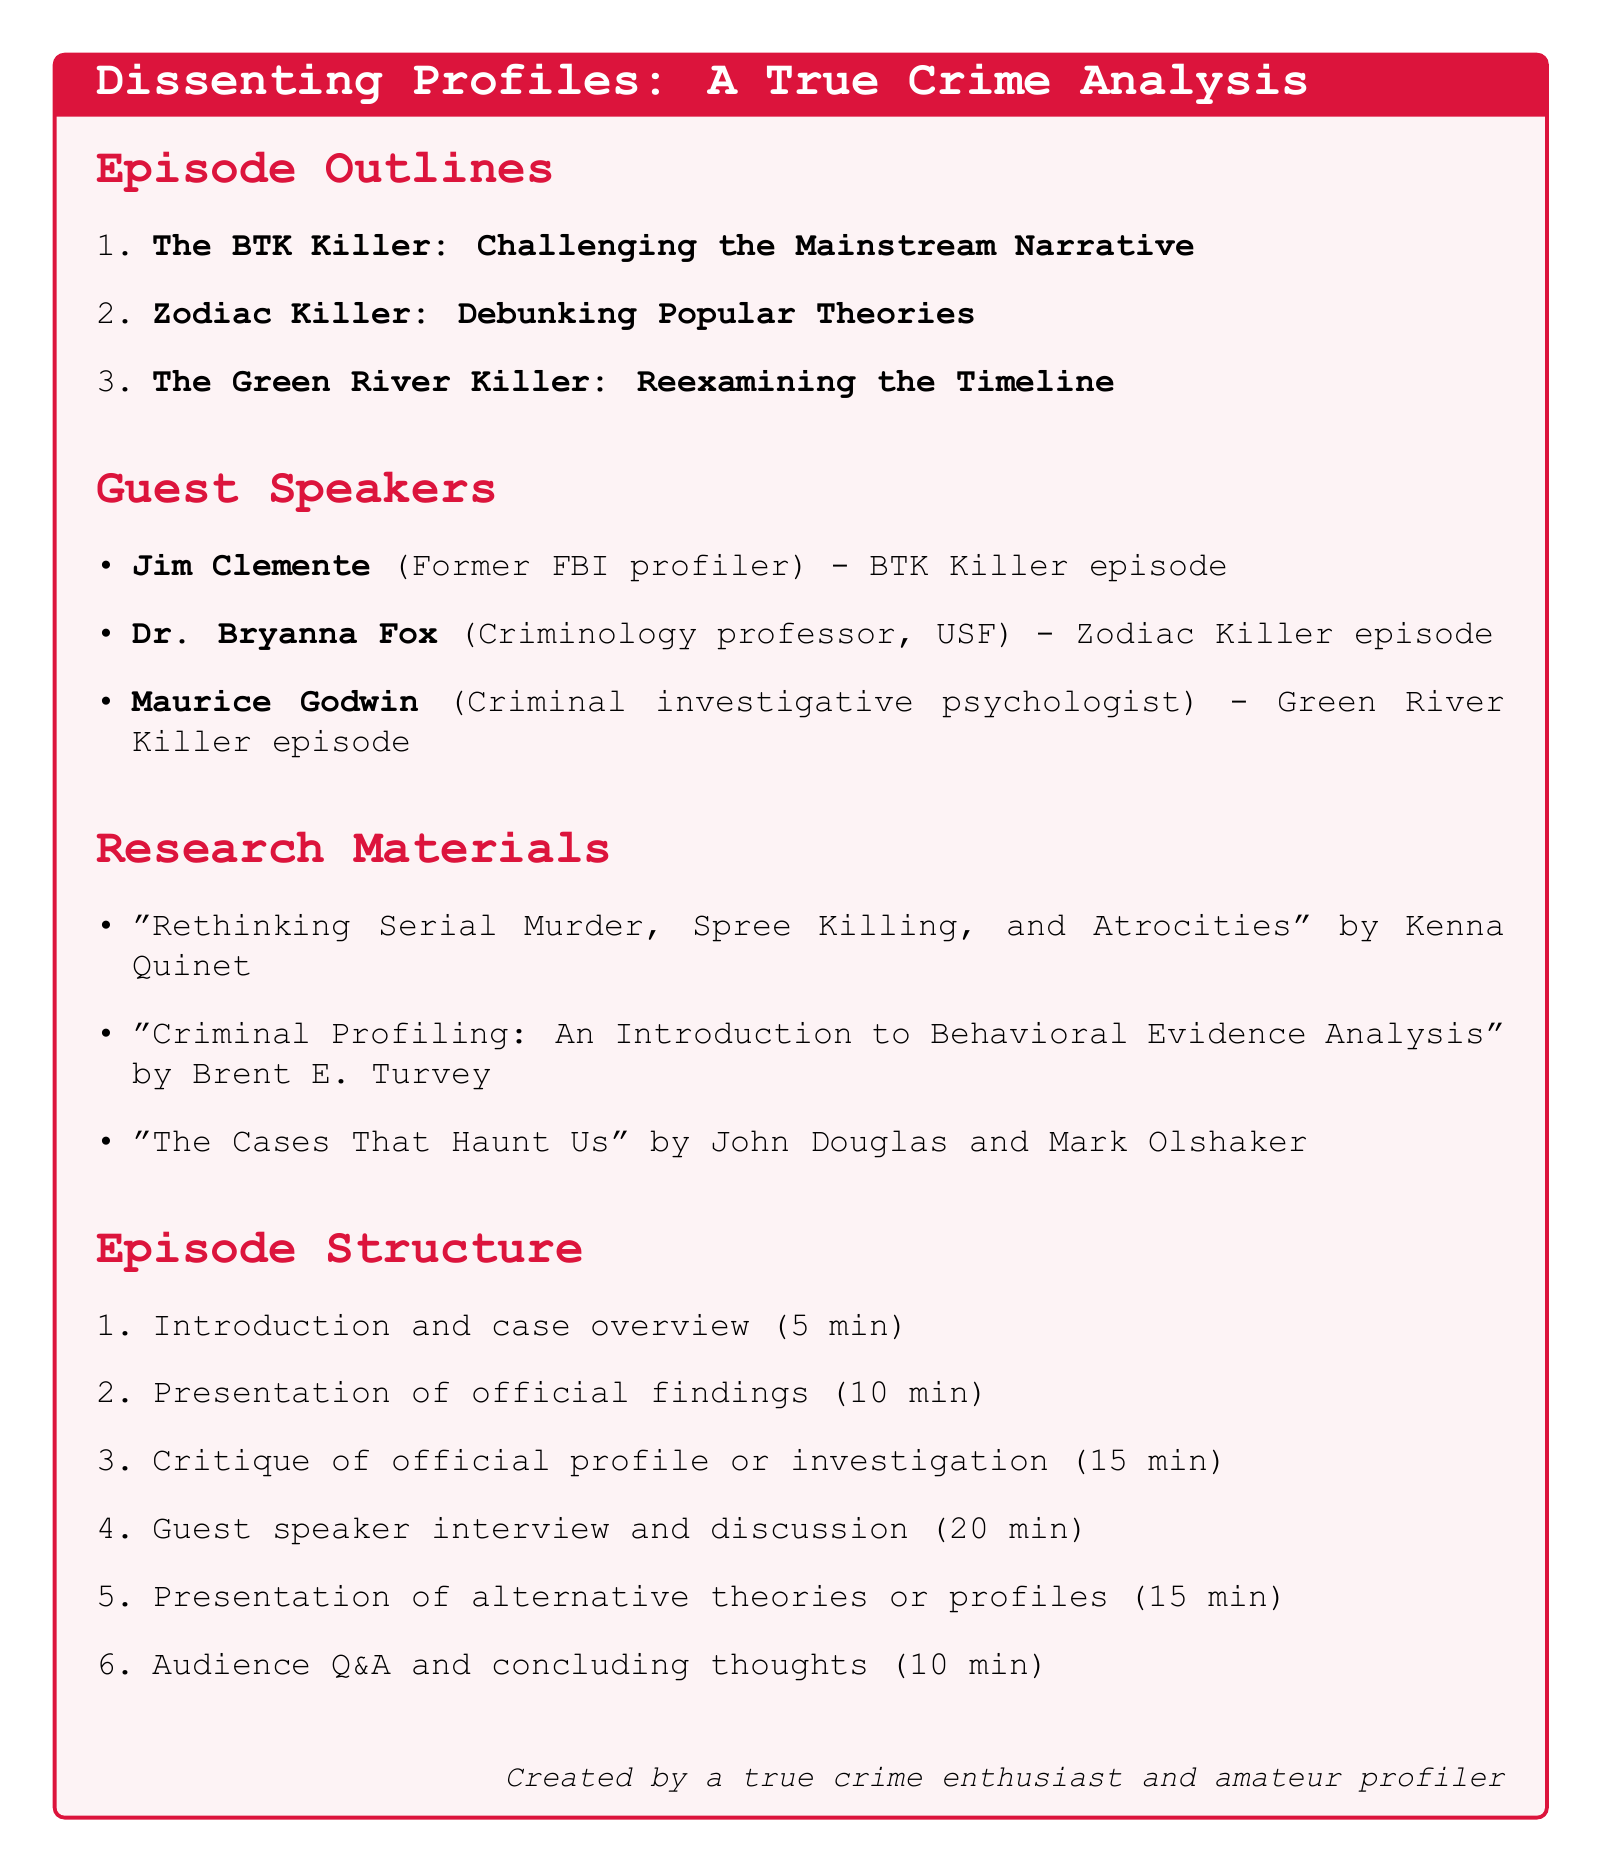What is the title of the podcast? The title of the podcast is explicitly stated at the beginning of the document, which is "Dissenting Profiles: A True Crime Analysis."
Answer: Dissenting Profiles: A True Crime Analysis How many episodes are outlined in the document? There are three episodes detailed in the outline section of the document.
Answer: 3 Who is the guest speaker for the Zodiac Killer episode? The guest speaker for the Zodiac Killer episode is clearly listed in the guest speakers section as Dr. Bryanna Fox.
Answer: Dr. Bryanna Fox What is the primary focus of Episode 1? The outline specifically mentions that Episode 1 focuses on the critique of the mainstream narrative surrounding the BTK Killer.
Answer: Challenging the Mainstream Narrative What is the total duration of the guest speaker interview segment? The duration for the guest speaker interview and discussion is given explicitly in the episode structure as 20 minutes.
Answer: 20 minutes Which research material critiques established profiling methods? The document lists "Criminal Profiling: An Introduction to Behavioral Evidence Analysis" by Brent E. Turvey as providing a foundation for critiquing established profiling methods.
Answer: Criminal Profiling: An Introduction to Behavioral Evidence Analysis What is the initial segment of the episode structure? The document states that the initial segment of the episode structure is the introduction and case overview.
Answer: Introduction and case overview What type of expertise does Maurice Godwin have? The document defines Maurice Godwin's expertise as a criminal investigative psychologist.
Answer: Criminal investigative psychologist In which episode does Jim Clemente participate as a guest speaker? The document indicates Jim Clemente participates in the BTK Killer episode.
Answer: BTK Killer 